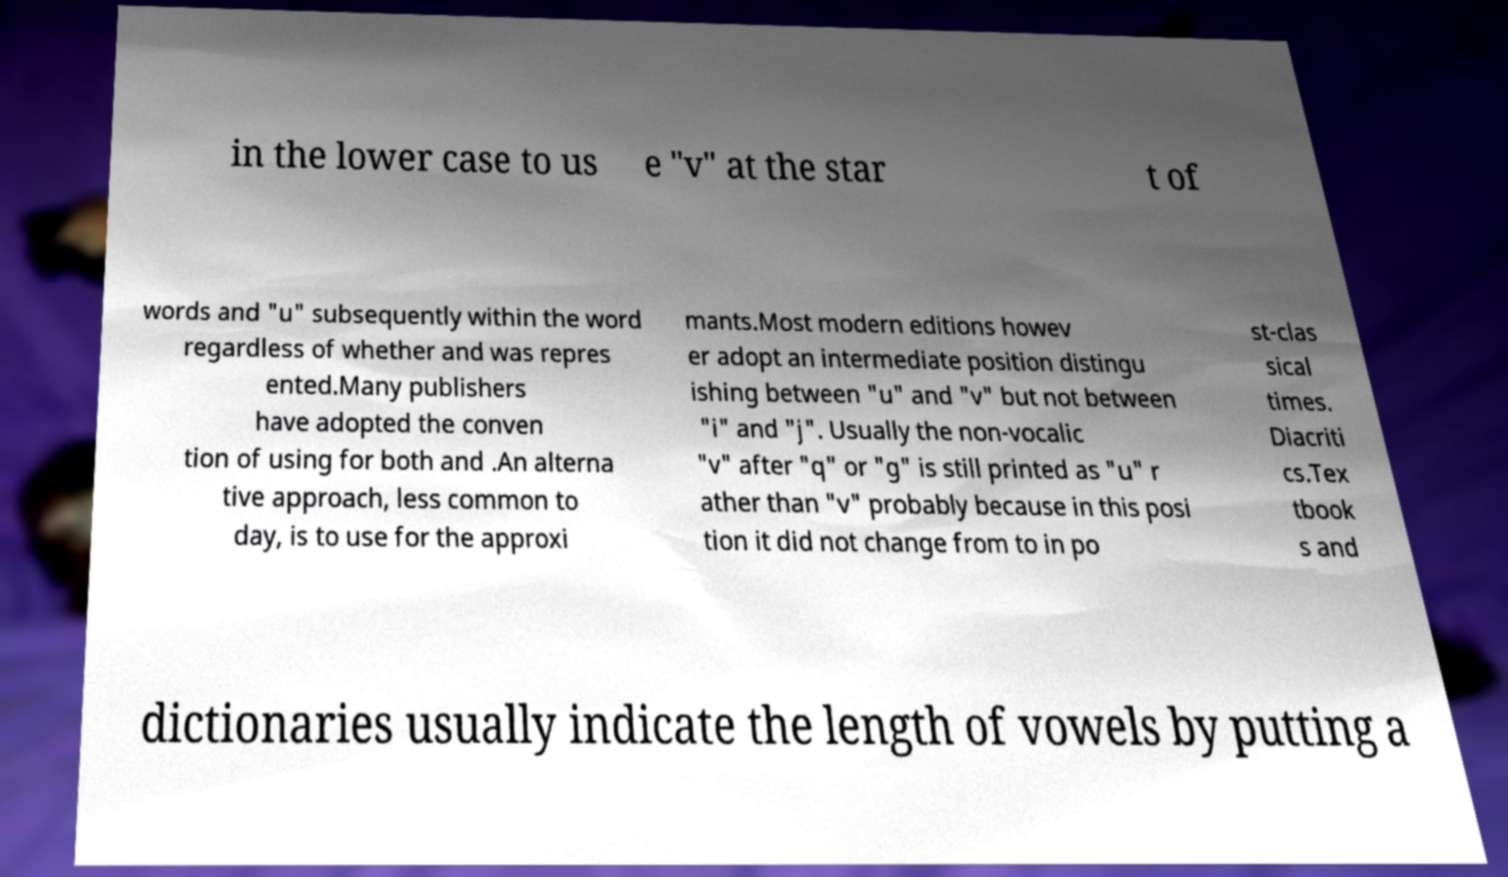There's text embedded in this image that I need extracted. Can you transcribe it verbatim? in the lower case to us e "v" at the star t of words and "u" subsequently within the word regardless of whether and was repres ented.Many publishers have adopted the conven tion of using for both and .An alterna tive approach, less common to day, is to use for the approxi mants.Most modern editions howev er adopt an intermediate position distingu ishing between "u" and "v" but not between "i" and "j". Usually the non-vocalic "v" after "q" or "g" is still printed as "u" r ather than "v" probably because in this posi tion it did not change from to in po st-clas sical times. Diacriti cs.Tex tbook s and dictionaries usually indicate the length of vowels by putting a 